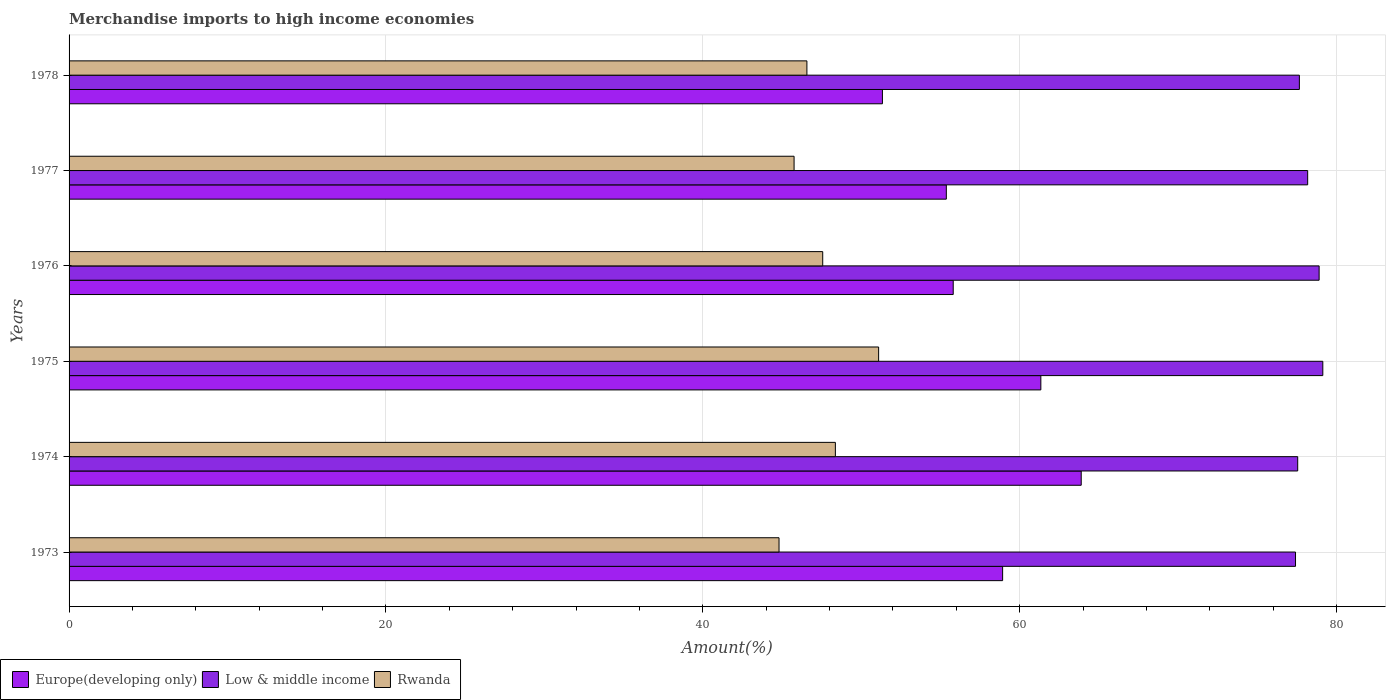How many different coloured bars are there?
Your answer should be very brief. 3. Are the number of bars on each tick of the Y-axis equal?
Offer a very short reply. Yes. How many bars are there on the 3rd tick from the bottom?
Your answer should be very brief. 3. What is the label of the 3rd group of bars from the top?
Offer a terse response. 1976. In how many cases, is the number of bars for a given year not equal to the number of legend labels?
Your response must be concise. 0. What is the percentage of amount earned from merchandise imports in Europe(developing only) in 1976?
Give a very brief answer. 55.8. Across all years, what is the maximum percentage of amount earned from merchandise imports in Europe(developing only)?
Keep it short and to the point. 63.88. Across all years, what is the minimum percentage of amount earned from merchandise imports in Europe(developing only)?
Your answer should be very brief. 51.34. In which year was the percentage of amount earned from merchandise imports in Low & middle income maximum?
Your answer should be very brief. 1975. What is the total percentage of amount earned from merchandise imports in Rwanda in the graph?
Your answer should be very brief. 284.17. What is the difference between the percentage of amount earned from merchandise imports in Rwanda in 1975 and that in 1977?
Provide a succinct answer. 5.34. What is the difference between the percentage of amount earned from merchandise imports in Europe(developing only) in 1977 and the percentage of amount earned from merchandise imports in Low & middle income in 1973?
Offer a terse response. -22.04. What is the average percentage of amount earned from merchandise imports in Europe(developing only) per year?
Your answer should be compact. 57.78. In the year 1974, what is the difference between the percentage of amount earned from merchandise imports in Low & middle income and percentage of amount earned from merchandise imports in Rwanda?
Offer a very short reply. 29.18. What is the ratio of the percentage of amount earned from merchandise imports in Rwanda in 1974 to that in 1978?
Provide a succinct answer. 1.04. Is the percentage of amount earned from merchandise imports in Low & middle income in 1974 less than that in 1978?
Provide a succinct answer. Yes. What is the difference between the highest and the second highest percentage of amount earned from merchandise imports in Rwanda?
Your answer should be very brief. 2.73. What is the difference between the highest and the lowest percentage of amount earned from merchandise imports in Europe(developing only)?
Offer a terse response. 12.55. Is the sum of the percentage of amount earned from merchandise imports in Europe(developing only) in 1973 and 1978 greater than the maximum percentage of amount earned from merchandise imports in Low & middle income across all years?
Your response must be concise. Yes. What does the 1st bar from the top in 1976 represents?
Provide a short and direct response. Rwanda. What does the 3rd bar from the bottom in 1977 represents?
Give a very brief answer. Rwanda. What is the difference between two consecutive major ticks on the X-axis?
Your response must be concise. 20. What is the title of the graph?
Make the answer very short. Merchandise imports to high income economies. What is the label or title of the X-axis?
Keep it short and to the point. Amount(%). What is the label or title of the Y-axis?
Your response must be concise. Years. What is the Amount(%) in Europe(developing only) in 1973?
Offer a terse response. 58.92. What is the Amount(%) of Low & middle income in 1973?
Ensure brevity in your answer.  77.41. What is the Amount(%) in Rwanda in 1973?
Give a very brief answer. 44.81. What is the Amount(%) of Europe(developing only) in 1974?
Provide a succinct answer. 63.88. What is the Amount(%) in Low & middle income in 1974?
Ensure brevity in your answer.  77.55. What is the Amount(%) in Rwanda in 1974?
Your answer should be very brief. 48.37. What is the Amount(%) of Europe(developing only) in 1975?
Give a very brief answer. 61.33. What is the Amount(%) of Low & middle income in 1975?
Your response must be concise. 79.13. What is the Amount(%) of Rwanda in 1975?
Ensure brevity in your answer.  51.1. What is the Amount(%) of Europe(developing only) in 1976?
Keep it short and to the point. 55.8. What is the Amount(%) in Low & middle income in 1976?
Offer a very short reply. 78.9. What is the Amount(%) in Rwanda in 1976?
Your answer should be compact. 47.57. What is the Amount(%) of Europe(developing only) in 1977?
Provide a short and direct response. 55.37. What is the Amount(%) of Low & middle income in 1977?
Your answer should be very brief. 78.18. What is the Amount(%) in Rwanda in 1977?
Give a very brief answer. 45.76. What is the Amount(%) of Europe(developing only) in 1978?
Make the answer very short. 51.34. What is the Amount(%) in Low & middle income in 1978?
Your answer should be very brief. 77.65. What is the Amount(%) in Rwanda in 1978?
Make the answer very short. 46.57. Across all years, what is the maximum Amount(%) in Europe(developing only)?
Give a very brief answer. 63.88. Across all years, what is the maximum Amount(%) in Low & middle income?
Provide a succinct answer. 79.13. Across all years, what is the maximum Amount(%) of Rwanda?
Give a very brief answer. 51.1. Across all years, what is the minimum Amount(%) in Europe(developing only)?
Your answer should be compact. 51.34. Across all years, what is the minimum Amount(%) in Low & middle income?
Give a very brief answer. 77.41. Across all years, what is the minimum Amount(%) in Rwanda?
Give a very brief answer. 44.81. What is the total Amount(%) in Europe(developing only) in the graph?
Offer a terse response. 346.65. What is the total Amount(%) of Low & middle income in the graph?
Make the answer very short. 468.82. What is the total Amount(%) of Rwanda in the graph?
Provide a short and direct response. 284.17. What is the difference between the Amount(%) in Europe(developing only) in 1973 and that in 1974?
Your answer should be compact. -4.96. What is the difference between the Amount(%) in Low & middle income in 1973 and that in 1974?
Your response must be concise. -0.14. What is the difference between the Amount(%) of Rwanda in 1973 and that in 1974?
Provide a short and direct response. -3.56. What is the difference between the Amount(%) of Europe(developing only) in 1973 and that in 1975?
Your response must be concise. -2.41. What is the difference between the Amount(%) of Low & middle income in 1973 and that in 1975?
Your response must be concise. -1.72. What is the difference between the Amount(%) in Rwanda in 1973 and that in 1975?
Your answer should be compact. -6.29. What is the difference between the Amount(%) of Europe(developing only) in 1973 and that in 1976?
Keep it short and to the point. 3.12. What is the difference between the Amount(%) in Low & middle income in 1973 and that in 1976?
Ensure brevity in your answer.  -1.49. What is the difference between the Amount(%) of Rwanda in 1973 and that in 1976?
Keep it short and to the point. -2.76. What is the difference between the Amount(%) in Europe(developing only) in 1973 and that in 1977?
Your answer should be compact. 3.55. What is the difference between the Amount(%) in Low & middle income in 1973 and that in 1977?
Your answer should be very brief. -0.77. What is the difference between the Amount(%) of Rwanda in 1973 and that in 1977?
Keep it short and to the point. -0.95. What is the difference between the Amount(%) in Europe(developing only) in 1973 and that in 1978?
Provide a short and direct response. 7.59. What is the difference between the Amount(%) of Low & middle income in 1973 and that in 1978?
Give a very brief answer. -0.24. What is the difference between the Amount(%) in Rwanda in 1973 and that in 1978?
Keep it short and to the point. -1.76. What is the difference between the Amount(%) of Europe(developing only) in 1974 and that in 1975?
Give a very brief answer. 2.55. What is the difference between the Amount(%) of Low & middle income in 1974 and that in 1975?
Give a very brief answer. -1.58. What is the difference between the Amount(%) of Rwanda in 1974 and that in 1975?
Provide a short and direct response. -2.73. What is the difference between the Amount(%) in Europe(developing only) in 1974 and that in 1976?
Make the answer very short. 8.08. What is the difference between the Amount(%) of Low & middle income in 1974 and that in 1976?
Offer a very short reply. -1.35. What is the difference between the Amount(%) in Rwanda in 1974 and that in 1976?
Your answer should be very brief. 0.8. What is the difference between the Amount(%) in Europe(developing only) in 1974 and that in 1977?
Make the answer very short. 8.51. What is the difference between the Amount(%) of Low & middle income in 1974 and that in 1977?
Provide a short and direct response. -0.63. What is the difference between the Amount(%) in Rwanda in 1974 and that in 1977?
Keep it short and to the point. 2.61. What is the difference between the Amount(%) in Europe(developing only) in 1974 and that in 1978?
Ensure brevity in your answer.  12.55. What is the difference between the Amount(%) of Low & middle income in 1974 and that in 1978?
Make the answer very short. -0.11. What is the difference between the Amount(%) in Rwanda in 1974 and that in 1978?
Your answer should be very brief. 1.8. What is the difference between the Amount(%) in Europe(developing only) in 1975 and that in 1976?
Your answer should be compact. 5.53. What is the difference between the Amount(%) of Low & middle income in 1975 and that in 1976?
Ensure brevity in your answer.  0.23. What is the difference between the Amount(%) in Rwanda in 1975 and that in 1976?
Your response must be concise. 3.53. What is the difference between the Amount(%) of Europe(developing only) in 1975 and that in 1977?
Provide a succinct answer. 5.96. What is the difference between the Amount(%) in Low & middle income in 1975 and that in 1977?
Your answer should be compact. 0.96. What is the difference between the Amount(%) of Rwanda in 1975 and that in 1977?
Offer a terse response. 5.34. What is the difference between the Amount(%) in Europe(developing only) in 1975 and that in 1978?
Your response must be concise. 10. What is the difference between the Amount(%) in Low & middle income in 1975 and that in 1978?
Provide a short and direct response. 1.48. What is the difference between the Amount(%) of Rwanda in 1975 and that in 1978?
Your response must be concise. 4.53. What is the difference between the Amount(%) of Europe(developing only) in 1976 and that in 1977?
Provide a succinct answer. 0.43. What is the difference between the Amount(%) in Low & middle income in 1976 and that in 1977?
Give a very brief answer. 0.72. What is the difference between the Amount(%) of Rwanda in 1976 and that in 1977?
Ensure brevity in your answer.  1.81. What is the difference between the Amount(%) in Europe(developing only) in 1976 and that in 1978?
Ensure brevity in your answer.  4.47. What is the difference between the Amount(%) in Low & middle income in 1976 and that in 1978?
Give a very brief answer. 1.25. What is the difference between the Amount(%) of Rwanda in 1976 and that in 1978?
Offer a very short reply. 1. What is the difference between the Amount(%) of Europe(developing only) in 1977 and that in 1978?
Provide a short and direct response. 4.03. What is the difference between the Amount(%) in Low & middle income in 1977 and that in 1978?
Your answer should be very brief. 0.52. What is the difference between the Amount(%) of Rwanda in 1977 and that in 1978?
Provide a succinct answer. -0.81. What is the difference between the Amount(%) in Europe(developing only) in 1973 and the Amount(%) in Low & middle income in 1974?
Make the answer very short. -18.62. What is the difference between the Amount(%) of Europe(developing only) in 1973 and the Amount(%) of Rwanda in 1974?
Provide a succinct answer. 10.56. What is the difference between the Amount(%) of Low & middle income in 1973 and the Amount(%) of Rwanda in 1974?
Ensure brevity in your answer.  29.04. What is the difference between the Amount(%) of Europe(developing only) in 1973 and the Amount(%) of Low & middle income in 1975?
Provide a short and direct response. -20.21. What is the difference between the Amount(%) in Europe(developing only) in 1973 and the Amount(%) in Rwanda in 1975?
Your answer should be very brief. 7.83. What is the difference between the Amount(%) in Low & middle income in 1973 and the Amount(%) in Rwanda in 1975?
Make the answer very short. 26.31. What is the difference between the Amount(%) of Europe(developing only) in 1973 and the Amount(%) of Low & middle income in 1976?
Ensure brevity in your answer.  -19.98. What is the difference between the Amount(%) in Europe(developing only) in 1973 and the Amount(%) in Rwanda in 1976?
Make the answer very short. 11.36. What is the difference between the Amount(%) of Low & middle income in 1973 and the Amount(%) of Rwanda in 1976?
Give a very brief answer. 29.84. What is the difference between the Amount(%) of Europe(developing only) in 1973 and the Amount(%) of Low & middle income in 1977?
Your response must be concise. -19.25. What is the difference between the Amount(%) of Europe(developing only) in 1973 and the Amount(%) of Rwanda in 1977?
Your answer should be compact. 13.16. What is the difference between the Amount(%) of Low & middle income in 1973 and the Amount(%) of Rwanda in 1977?
Offer a very short reply. 31.65. What is the difference between the Amount(%) in Europe(developing only) in 1973 and the Amount(%) in Low & middle income in 1978?
Your response must be concise. -18.73. What is the difference between the Amount(%) in Europe(developing only) in 1973 and the Amount(%) in Rwanda in 1978?
Provide a short and direct response. 12.35. What is the difference between the Amount(%) of Low & middle income in 1973 and the Amount(%) of Rwanda in 1978?
Your response must be concise. 30.84. What is the difference between the Amount(%) of Europe(developing only) in 1974 and the Amount(%) of Low & middle income in 1975?
Your answer should be very brief. -15.25. What is the difference between the Amount(%) of Europe(developing only) in 1974 and the Amount(%) of Rwanda in 1975?
Ensure brevity in your answer.  12.79. What is the difference between the Amount(%) in Low & middle income in 1974 and the Amount(%) in Rwanda in 1975?
Provide a short and direct response. 26.45. What is the difference between the Amount(%) of Europe(developing only) in 1974 and the Amount(%) of Low & middle income in 1976?
Offer a terse response. -15.02. What is the difference between the Amount(%) in Europe(developing only) in 1974 and the Amount(%) in Rwanda in 1976?
Your response must be concise. 16.32. What is the difference between the Amount(%) in Low & middle income in 1974 and the Amount(%) in Rwanda in 1976?
Your response must be concise. 29.98. What is the difference between the Amount(%) in Europe(developing only) in 1974 and the Amount(%) in Low & middle income in 1977?
Provide a short and direct response. -14.29. What is the difference between the Amount(%) in Europe(developing only) in 1974 and the Amount(%) in Rwanda in 1977?
Offer a terse response. 18.12. What is the difference between the Amount(%) of Low & middle income in 1974 and the Amount(%) of Rwanda in 1977?
Your answer should be very brief. 31.79. What is the difference between the Amount(%) of Europe(developing only) in 1974 and the Amount(%) of Low & middle income in 1978?
Ensure brevity in your answer.  -13.77. What is the difference between the Amount(%) of Europe(developing only) in 1974 and the Amount(%) of Rwanda in 1978?
Offer a very short reply. 17.31. What is the difference between the Amount(%) in Low & middle income in 1974 and the Amount(%) in Rwanda in 1978?
Give a very brief answer. 30.98. What is the difference between the Amount(%) of Europe(developing only) in 1975 and the Amount(%) of Low & middle income in 1976?
Ensure brevity in your answer.  -17.57. What is the difference between the Amount(%) of Europe(developing only) in 1975 and the Amount(%) of Rwanda in 1976?
Provide a succinct answer. 13.77. What is the difference between the Amount(%) of Low & middle income in 1975 and the Amount(%) of Rwanda in 1976?
Make the answer very short. 31.56. What is the difference between the Amount(%) of Europe(developing only) in 1975 and the Amount(%) of Low & middle income in 1977?
Make the answer very short. -16.84. What is the difference between the Amount(%) in Europe(developing only) in 1975 and the Amount(%) in Rwanda in 1977?
Give a very brief answer. 15.57. What is the difference between the Amount(%) of Low & middle income in 1975 and the Amount(%) of Rwanda in 1977?
Your response must be concise. 33.37. What is the difference between the Amount(%) in Europe(developing only) in 1975 and the Amount(%) in Low & middle income in 1978?
Your answer should be compact. -16.32. What is the difference between the Amount(%) in Europe(developing only) in 1975 and the Amount(%) in Rwanda in 1978?
Keep it short and to the point. 14.77. What is the difference between the Amount(%) of Low & middle income in 1975 and the Amount(%) of Rwanda in 1978?
Ensure brevity in your answer.  32.56. What is the difference between the Amount(%) in Europe(developing only) in 1976 and the Amount(%) in Low & middle income in 1977?
Offer a terse response. -22.37. What is the difference between the Amount(%) of Europe(developing only) in 1976 and the Amount(%) of Rwanda in 1977?
Ensure brevity in your answer.  10.04. What is the difference between the Amount(%) in Low & middle income in 1976 and the Amount(%) in Rwanda in 1977?
Provide a short and direct response. 33.14. What is the difference between the Amount(%) of Europe(developing only) in 1976 and the Amount(%) of Low & middle income in 1978?
Give a very brief answer. -21.85. What is the difference between the Amount(%) in Europe(developing only) in 1976 and the Amount(%) in Rwanda in 1978?
Ensure brevity in your answer.  9.23. What is the difference between the Amount(%) of Low & middle income in 1976 and the Amount(%) of Rwanda in 1978?
Make the answer very short. 32.33. What is the difference between the Amount(%) of Europe(developing only) in 1977 and the Amount(%) of Low & middle income in 1978?
Offer a very short reply. -22.28. What is the difference between the Amount(%) in Europe(developing only) in 1977 and the Amount(%) in Rwanda in 1978?
Keep it short and to the point. 8.8. What is the difference between the Amount(%) of Low & middle income in 1977 and the Amount(%) of Rwanda in 1978?
Keep it short and to the point. 31.61. What is the average Amount(%) of Europe(developing only) per year?
Provide a short and direct response. 57.78. What is the average Amount(%) in Low & middle income per year?
Your answer should be very brief. 78.14. What is the average Amount(%) in Rwanda per year?
Give a very brief answer. 47.36. In the year 1973, what is the difference between the Amount(%) in Europe(developing only) and Amount(%) in Low & middle income?
Ensure brevity in your answer.  -18.49. In the year 1973, what is the difference between the Amount(%) of Europe(developing only) and Amount(%) of Rwanda?
Offer a very short reply. 14.11. In the year 1973, what is the difference between the Amount(%) in Low & middle income and Amount(%) in Rwanda?
Your response must be concise. 32.6. In the year 1974, what is the difference between the Amount(%) of Europe(developing only) and Amount(%) of Low & middle income?
Offer a very short reply. -13.66. In the year 1974, what is the difference between the Amount(%) in Europe(developing only) and Amount(%) in Rwanda?
Keep it short and to the point. 15.52. In the year 1974, what is the difference between the Amount(%) of Low & middle income and Amount(%) of Rwanda?
Your answer should be very brief. 29.18. In the year 1975, what is the difference between the Amount(%) of Europe(developing only) and Amount(%) of Low & middle income?
Provide a short and direct response. -17.8. In the year 1975, what is the difference between the Amount(%) of Europe(developing only) and Amount(%) of Rwanda?
Give a very brief answer. 10.24. In the year 1975, what is the difference between the Amount(%) of Low & middle income and Amount(%) of Rwanda?
Your response must be concise. 28.04. In the year 1976, what is the difference between the Amount(%) of Europe(developing only) and Amount(%) of Low & middle income?
Keep it short and to the point. -23.1. In the year 1976, what is the difference between the Amount(%) of Europe(developing only) and Amount(%) of Rwanda?
Your answer should be very brief. 8.24. In the year 1976, what is the difference between the Amount(%) of Low & middle income and Amount(%) of Rwanda?
Your response must be concise. 31.33. In the year 1977, what is the difference between the Amount(%) in Europe(developing only) and Amount(%) in Low & middle income?
Offer a very short reply. -22.81. In the year 1977, what is the difference between the Amount(%) in Europe(developing only) and Amount(%) in Rwanda?
Keep it short and to the point. 9.61. In the year 1977, what is the difference between the Amount(%) of Low & middle income and Amount(%) of Rwanda?
Provide a succinct answer. 32.42. In the year 1978, what is the difference between the Amount(%) of Europe(developing only) and Amount(%) of Low & middle income?
Offer a very short reply. -26.32. In the year 1978, what is the difference between the Amount(%) in Europe(developing only) and Amount(%) in Rwanda?
Offer a very short reply. 4.77. In the year 1978, what is the difference between the Amount(%) of Low & middle income and Amount(%) of Rwanda?
Ensure brevity in your answer.  31.08. What is the ratio of the Amount(%) in Europe(developing only) in 1973 to that in 1974?
Your response must be concise. 0.92. What is the ratio of the Amount(%) of Low & middle income in 1973 to that in 1974?
Ensure brevity in your answer.  1. What is the ratio of the Amount(%) of Rwanda in 1973 to that in 1974?
Your response must be concise. 0.93. What is the ratio of the Amount(%) in Europe(developing only) in 1973 to that in 1975?
Make the answer very short. 0.96. What is the ratio of the Amount(%) in Low & middle income in 1973 to that in 1975?
Your answer should be compact. 0.98. What is the ratio of the Amount(%) in Rwanda in 1973 to that in 1975?
Make the answer very short. 0.88. What is the ratio of the Amount(%) of Europe(developing only) in 1973 to that in 1976?
Offer a very short reply. 1.06. What is the ratio of the Amount(%) of Low & middle income in 1973 to that in 1976?
Your response must be concise. 0.98. What is the ratio of the Amount(%) of Rwanda in 1973 to that in 1976?
Your answer should be very brief. 0.94. What is the ratio of the Amount(%) in Europe(developing only) in 1973 to that in 1977?
Your answer should be very brief. 1.06. What is the ratio of the Amount(%) in Low & middle income in 1973 to that in 1977?
Make the answer very short. 0.99. What is the ratio of the Amount(%) in Rwanda in 1973 to that in 1977?
Ensure brevity in your answer.  0.98. What is the ratio of the Amount(%) in Europe(developing only) in 1973 to that in 1978?
Your answer should be very brief. 1.15. What is the ratio of the Amount(%) of Rwanda in 1973 to that in 1978?
Provide a short and direct response. 0.96. What is the ratio of the Amount(%) in Europe(developing only) in 1974 to that in 1975?
Your response must be concise. 1.04. What is the ratio of the Amount(%) of Rwanda in 1974 to that in 1975?
Provide a short and direct response. 0.95. What is the ratio of the Amount(%) of Europe(developing only) in 1974 to that in 1976?
Provide a succinct answer. 1.14. What is the ratio of the Amount(%) in Low & middle income in 1974 to that in 1976?
Keep it short and to the point. 0.98. What is the ratio of the Amount(%) of Rwanda in 1974 to that in 1976?
Provide a succinct answer. 1.02. What is the ratio of the Amount(%) in Europe(developing only) in 1974 to that in 1977?
Your answer should be very brief. 1.15. What is the ratio of the Amount(%) in Low & middle income in 1974 to that in 1977?
Make the answer very short. 0.99. What is the ratio of the Amount(%) of Rwanda in 1974 to that in 1977?
Provide a succinct answer. 1.06. What is the ratio of the Amount(%) of Europe(developing only) in 1974 to that in 1978?
Offer a terse response. 1.24. What is the ratio of the Amount(%) of Rwanda in 1974 to that in 1978?
Your answer should be compact. 1.04. What is the ratio of the Amount(%) in Europe(developing only) in 1975 to that in 1976?
Your response must be concise. 1.1. What is the ratio of the Amount(%) of Low & middle income in 1975 to that in 1976?
Give a very brief answer. 1. What is the ratio of the Amount(%) in Rwanda in 1975 to that in 1976?
Ensure brevity in your answer.  1.07. What is the ratio of the Amount(%) in Europe(developing only) in 1975 to that in 1977?
Offer a very short reply. 1.11. What is the ratio of the Amount(%) of Low & middle income in 1975 to that in 1977?
Keep it short and to the point. 1.01. What is the ratio of the Amount(%) of Rwanda in 1975 to that in 1977?
Provide a succinct answer. 1.12. What is the ratio of the Amount(%) in Europe(developing only) in 1975 to that in 1978?
Ensure brevity in your answer.  1.19. What is the ratio of the Amount(%) of Rwanda in 1975 to that in 1978?
Give a very brief answer. 1.1. What is the ratio of the Amount(%) of Low & middle income in 1976 to that in 1977?
Keep it short and to the point. 1.01. What is the ratio of the Amount(%) of Rwanda in 1976 to that in 1977?
Provide a short and direct response. 1.04. What is the ratio of the Amount(%) of Europe(developing only) in 1976 to that in 1978?
Your answer should be very brief. 1.09. What is the ratio of the Amount(%) in Low & middle income in 1976 to that in 1978?
Provide a succinct answer. 1.02. What is the ratio of the Amount(%) of Rwanda in 1976 to that in 1978?
Your answer should be compact. 1.02. What is the ratio of the Amount(%) in Europe(developing only) in 1977 to that in 1978?
Provide a succinct answer. 1.08. What is the ratio of the Amount(%) of Low & middle income in 1977 to that in 1978?
Provide a short and direct response. 1.01. What is the ratio of the Amount(%) in Rwanda in 1977 to that in 1978?
Your answer should be very brief. 0.98. What is the difference between the highest and the second highest Amount(%) in Europe(developing only)?
Your answer should be compact. 2.55. What is the difference between the highest and the second highest Amount(%) in Low & middle income?
Provide a succinct answer. 0.23. What is the difference between the highest and the second highest Amount(%) of Rwanda?
Make the answer very short. 2.73. What is the difference between the highest and the lowest Amount(%) in Europe(developing only)?
Your response must be concise. 12.55. What is the difference between the highest and the lowest Amount(%) in Low & middle income?
Offer a terse response. 1.72. What is the difference between the highest and the lowest Amount(%) in Rwanda?
Provide a short and direct response. 6.29. 